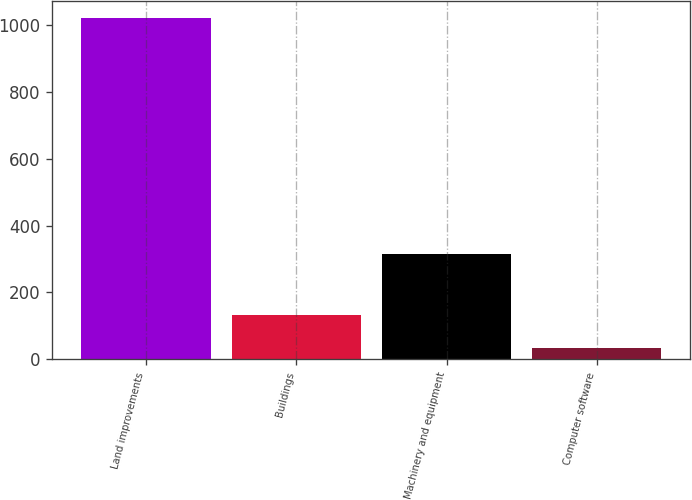Convert chart to OTSL. <chart><loc_0><loc_0><loc_500><loc_500><bar_chart><fcel>Land improvements<fcel>Buildings<fcel>Machinery and equipment<fcel>Computer software<nl><fcel>1020<fcel>133.5<fcel>315<fcel>35<nl></chart> 